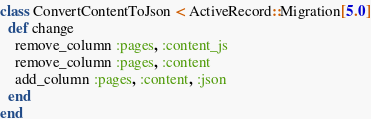Convert code to text. <code><loc_0><loc_0><loc_500><loc_500><_Ruby_>class ConvertContentToJson < ActiveRecord::Migration[5.0]
  def change
    remove_column :pages, :content_js
    remove_column :pages, :content
    add_column :pages, :content, :json
  end
end
</code> 